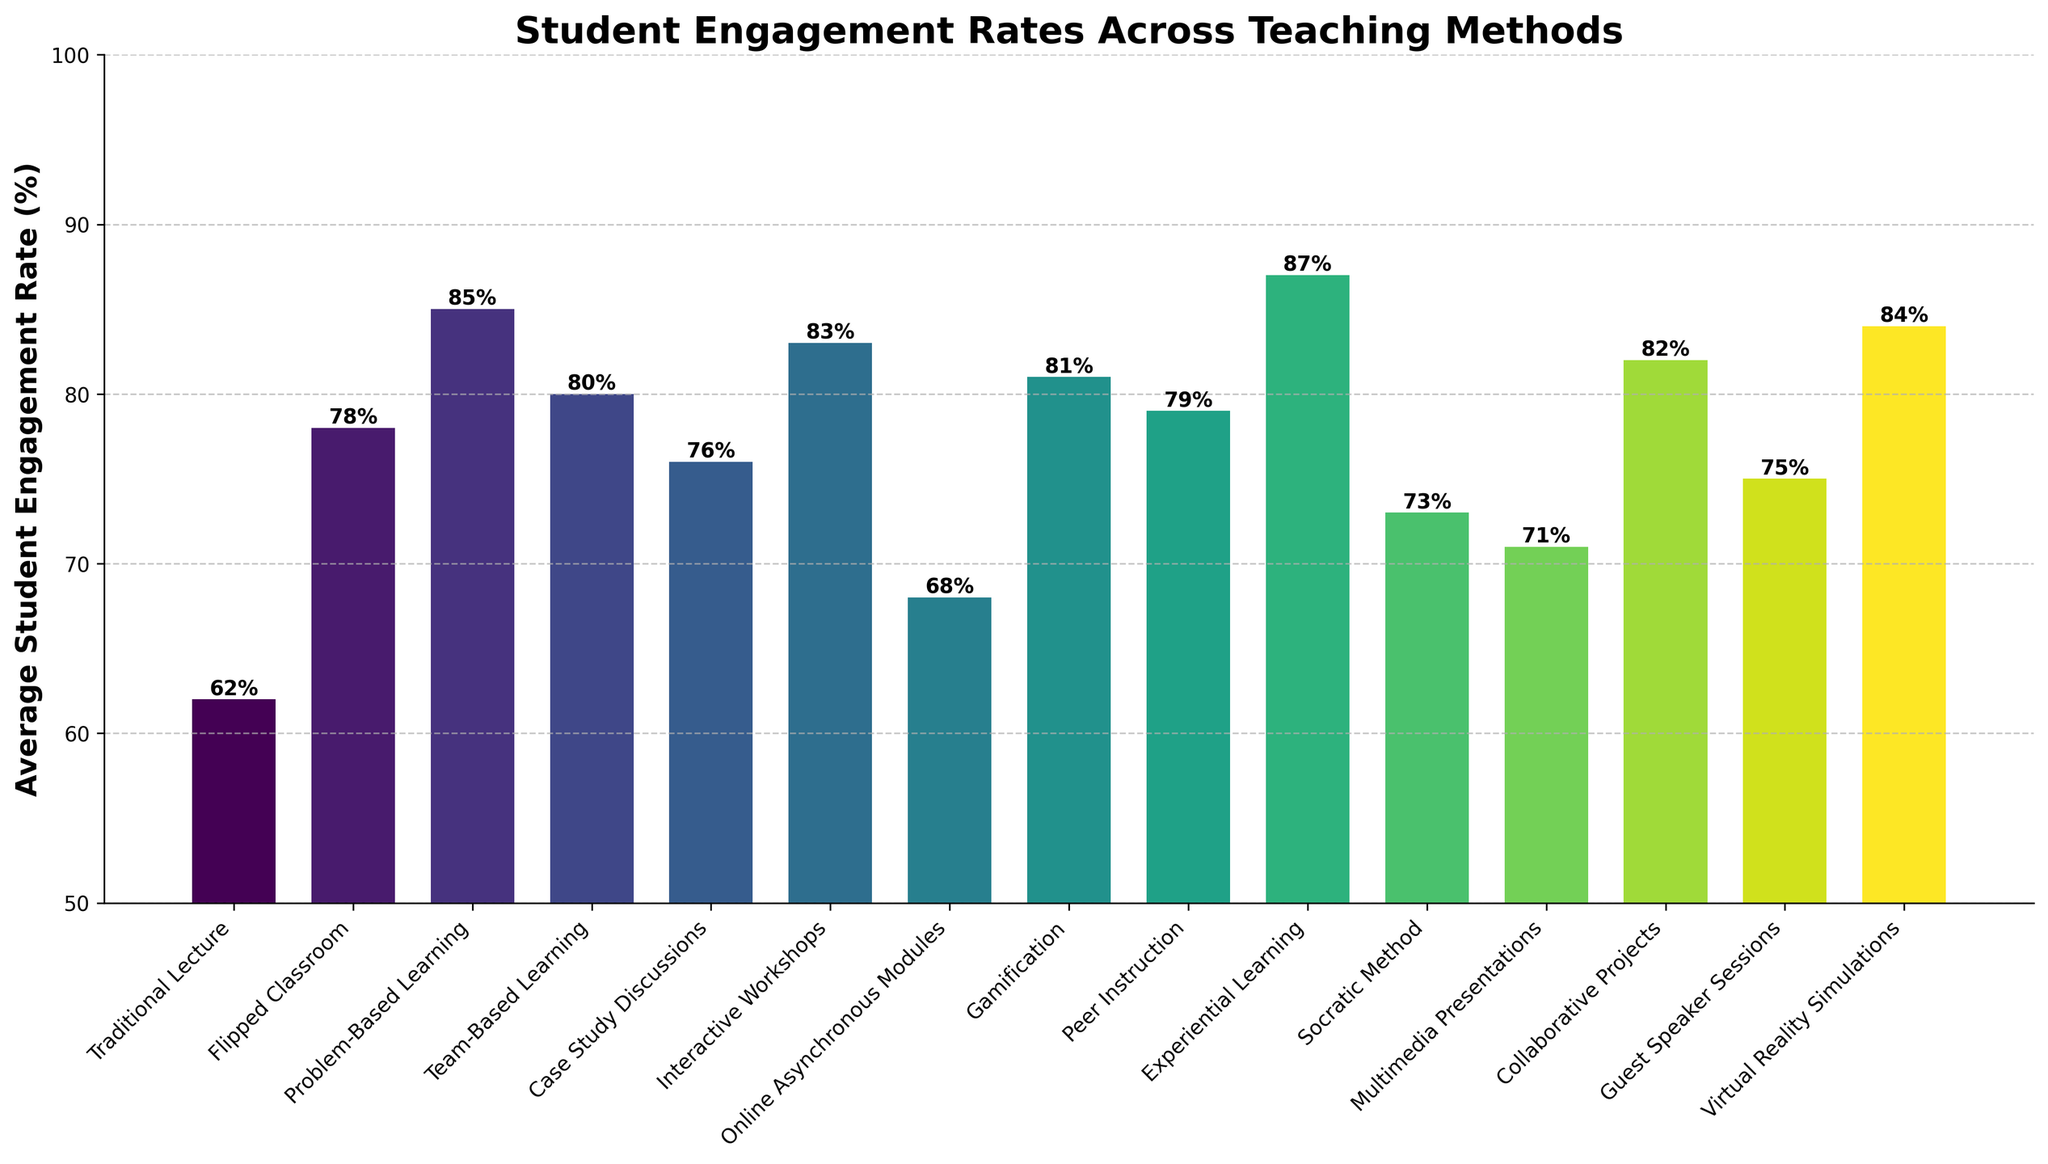What's the least engaging teaching method according to the chart? The least engaging teaching method can be identified by finding the bar with the lowest height, representing the smallest percentage.
Answer: Traditional Lecture Which teaching method has an engagement rate closest to 80%? To find the teaching method closest to 80%, look for bars with heights near this value. Both Team-Based Learning (80%) and Peer Instruction (79%) are close, with Team-Based Learning being exact.
Answer: Team-Based Learning What is the difference in engagement rates between Interactive Workshops and Online Asynchronous Modules? Calculate the difference by subtracting the engagement rate of Online Asynchronous Modules (68%) from that of Interactive Workshops (83%).
Answer: 15% Which teaching method shows the highest average student engagement rate? Locate the bar with the greatest height on the chart, which represents the highest percentage.
Answer: Experiential Learning Between Gamification and Case Study Discussions, which has a higher average engagement rate? Compare the heights of the bars for Gamification (81%) and Case Study Discussions (76%).
Answer: Gamification How many teaching methods have an engagement rate above 80%? Count the number of bars that extend above the 80% line. These methods include Problem-Based Learning, Interactive Workshops, Gamification, Experiential Learning, Collaborative Projects, and Virtual Reality Simulations.
Answer: 6 What is the combined average engagement rate of Flipped Classroom and Socratic Method? Add the engagement rates for Flipped Classroom (78%) and Socratic Method (73%), then divide by 2 to find the combined average.
Answer: 75.5% Does Peer Instruction have a higher engagement rate compared to Multimedia Presentations? Compare the heights of the bars for Peer Instruction (79%) and Multimedia Presentations (71%).
Answer: Yes Which teaching methods have an engagement rate that falls between 70% and 75%? Identify bars with heights corresponding to percentages between 70% and 75%. The methods are Multimedia Presentations (71%), Socratic Method (73%), and Guest Speaker Sessions (75%).
Answer: Multimedia Presentations, Socratic Method, Guest Speaker Sessions List the top three teaching methods in terms of student engagement rate. Rank the teaching methods by the height of their bars. The top three are Experiential Learning (87%), Problem-Based Learning (85%), and Virtual Reality Simulations (84%).
Answer: Experiential Learning, Problem-Based Learning, Virtual Reality Simulations 